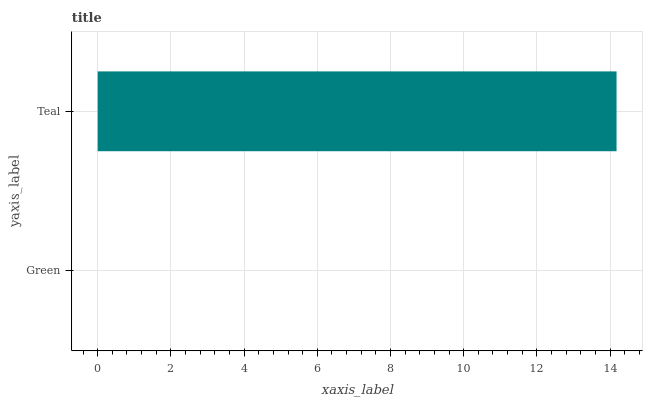Is Green the minimum?
Answer yes or no. Yes. Is Teal the maximum?
Answer yes or no. Yes. Is Teal the minimum?
Answer yes or no. No. Is Teal greater than Green?
Answer yes or no. Yes. Is Green less than Teal?
Answer yes or no. Yes. Is Green greater than Teal?
Answer yes or no. No. Is Teal less than Green?
Answer yes or no. No. Is Teal the high median?
Answer yes or no. Yes. Is Green the low median?
Answer yes or no. Yes. Is Green the high median?
Answer yes or no. No. Is Teal the low median?
Answer yes or no. No. 